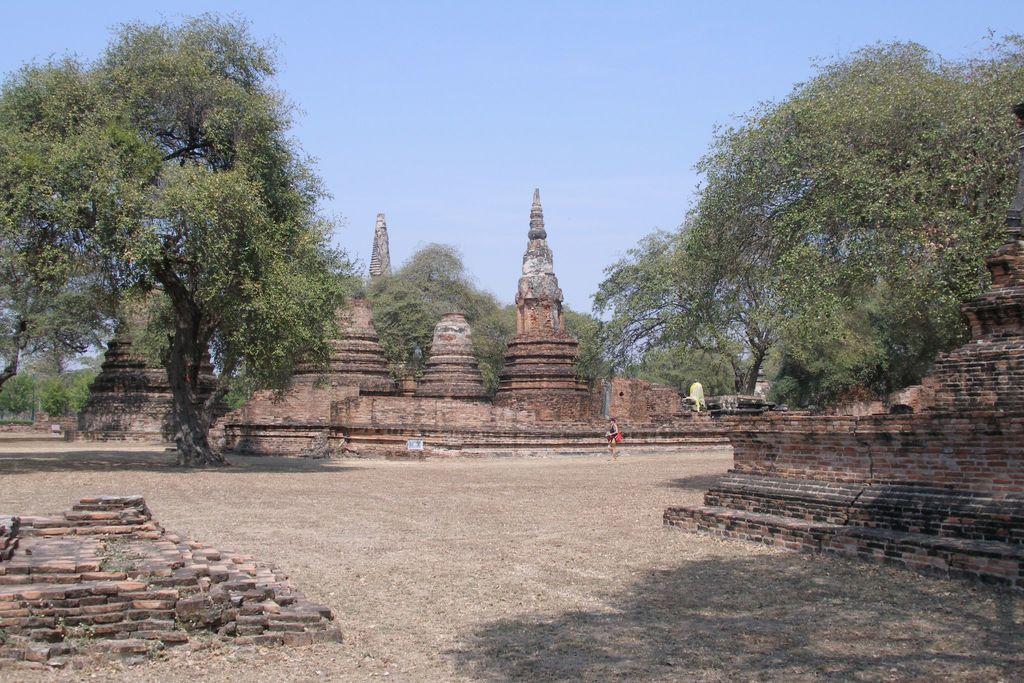How would you summarize this image in a sentence or two? In this image at the center there are brick structures and trees. There is grass on the surface. At the background there is sky. 